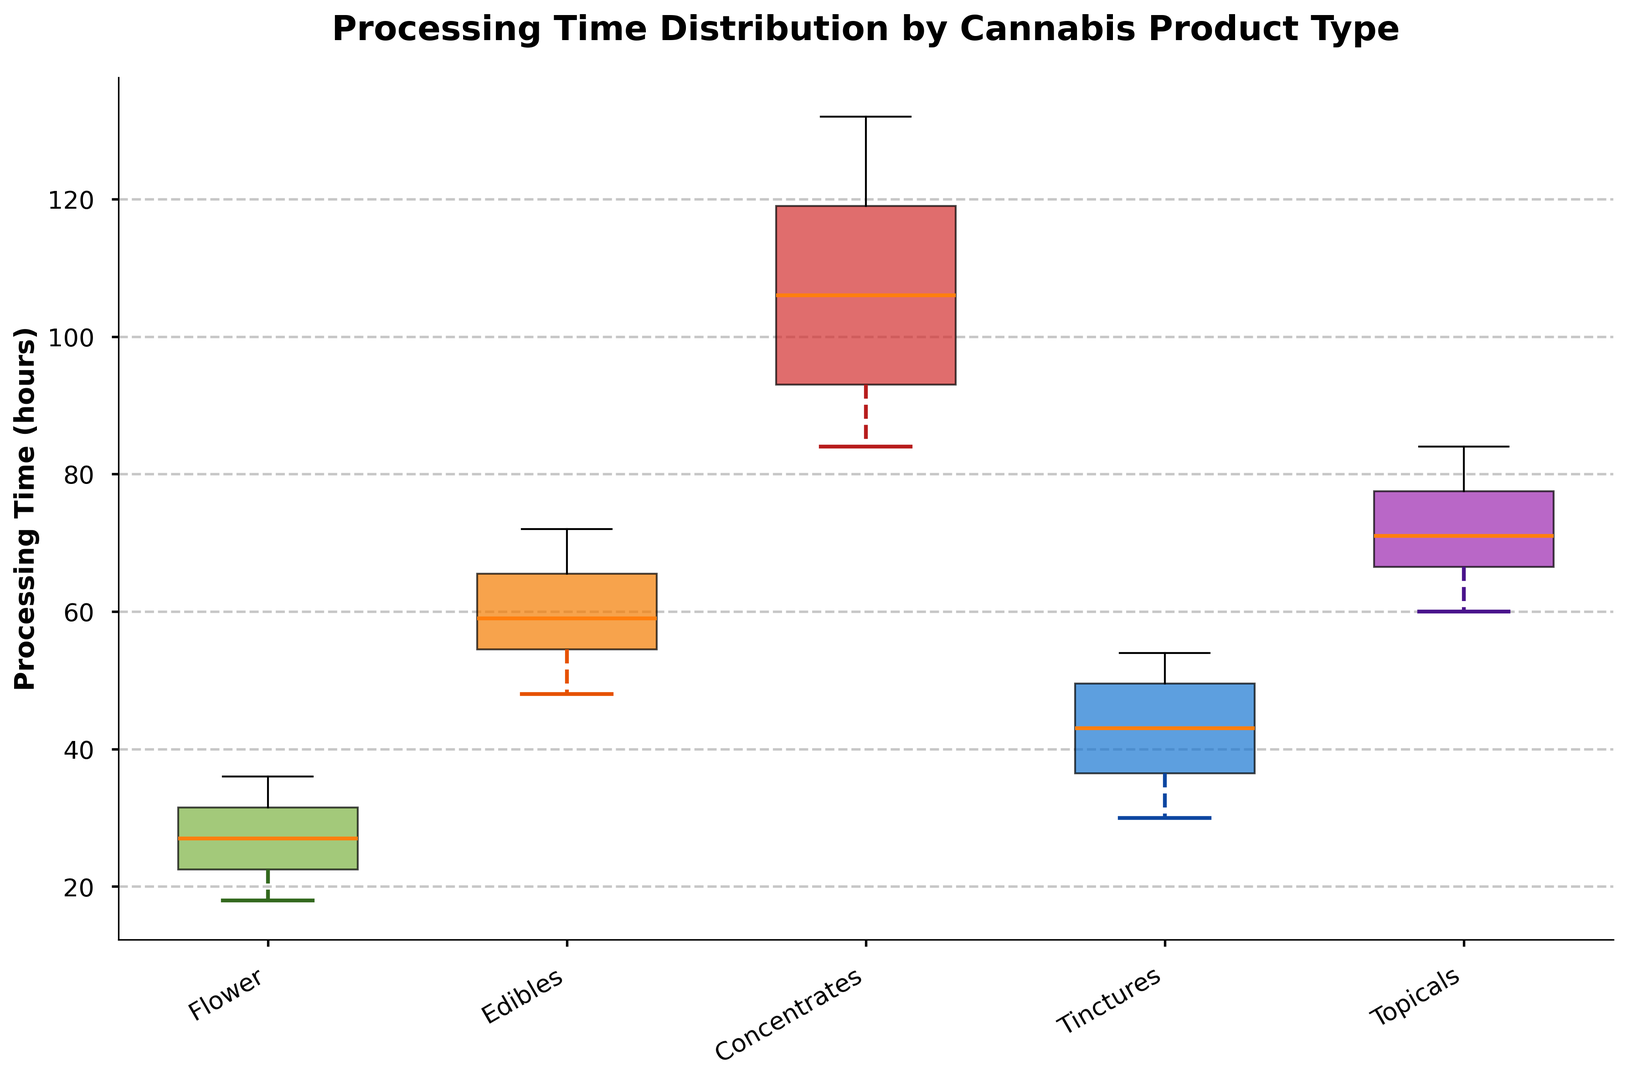What's the median processing time for Tinctures? The median is the middle value of the dataset when ordered. For Tinctures, the processing times are sorted as [30, 32, 36, 38, 42, 44, 48, 50, 52, 54]. The middle values are 42 and 44, hence the median is (42 + 44) / 2 = 43.
Answer: 43 Which product type has the highest median processing time? To determine the product type with the highest median, compare the median values of all product types. The medians are as follows: Flower (26), Edibles (58), Concentrates (108), Tinctures (43), Topicals (70). Concentrates has the highest median value.
Answer: Concentrates What is the range of processing times for the Flower product type? The range is the difference between the maximum and minimum values of the dataset. For Flower, the dataset is [18, 20, 22, 24, 26, 28, 30, 32, 34, 36]. The range is 36 - 18 = 18.
Answer: 18 Which product type exhibits the greatest spread in processing times? The spread can be assessed by looking at the length of the boxplots and whiskers. Concentrates show the widest spread, with values ranging from 84 to 132, compared to other product types.
Answer: Concentrates How does the interquartile range (IQR) for Edibles compare to that of Topicals? The IQR is the difference between the third quartile (Q3) and the first quartile (Q1). For Edibles, Q3 is around 64, and Q1 is about 52, so IQR = 64 - 52 = 12. For Topicals, Q3 is around 78, and Q1 is about 62, so IQR = 78 - 62 = 16. Topicals have a larger IQR.
Answer: Topicals have a larger IQR Which product type has the smallest lower whisker? The lower whisker represents the minimum value. By examining the whiskers, the Flower product type has the smallest lower whisker, which touches the 18 mark.
Answer: Flower What is the median difference in processing time between Edibles and Topicals? The median processing time for Edibles is 58, and for Topicals, it is 70. The difference is 70 - 58 = 12.
Answer: 12 Which product type has whiskers that are almost equidistant from the median? By inspecting the plot, Tinctures have whiskers that appear nearly equally spread above and below the median.
Answer: Tinctures 